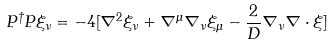<formula> <loc_0><loc_0><loc_500><loc_500>P ^ { \dag } P \xi _ { \nu } = - 4 [ \nabla ^ { 2 } \xi _ { \nu } + \nabla ^ { \mu } \nabla _ { \nu } \xi _ { \mu } - \frac { 2 } { D } \nabla _ { \nu } \nabla \cdot \xi ]</formula> 